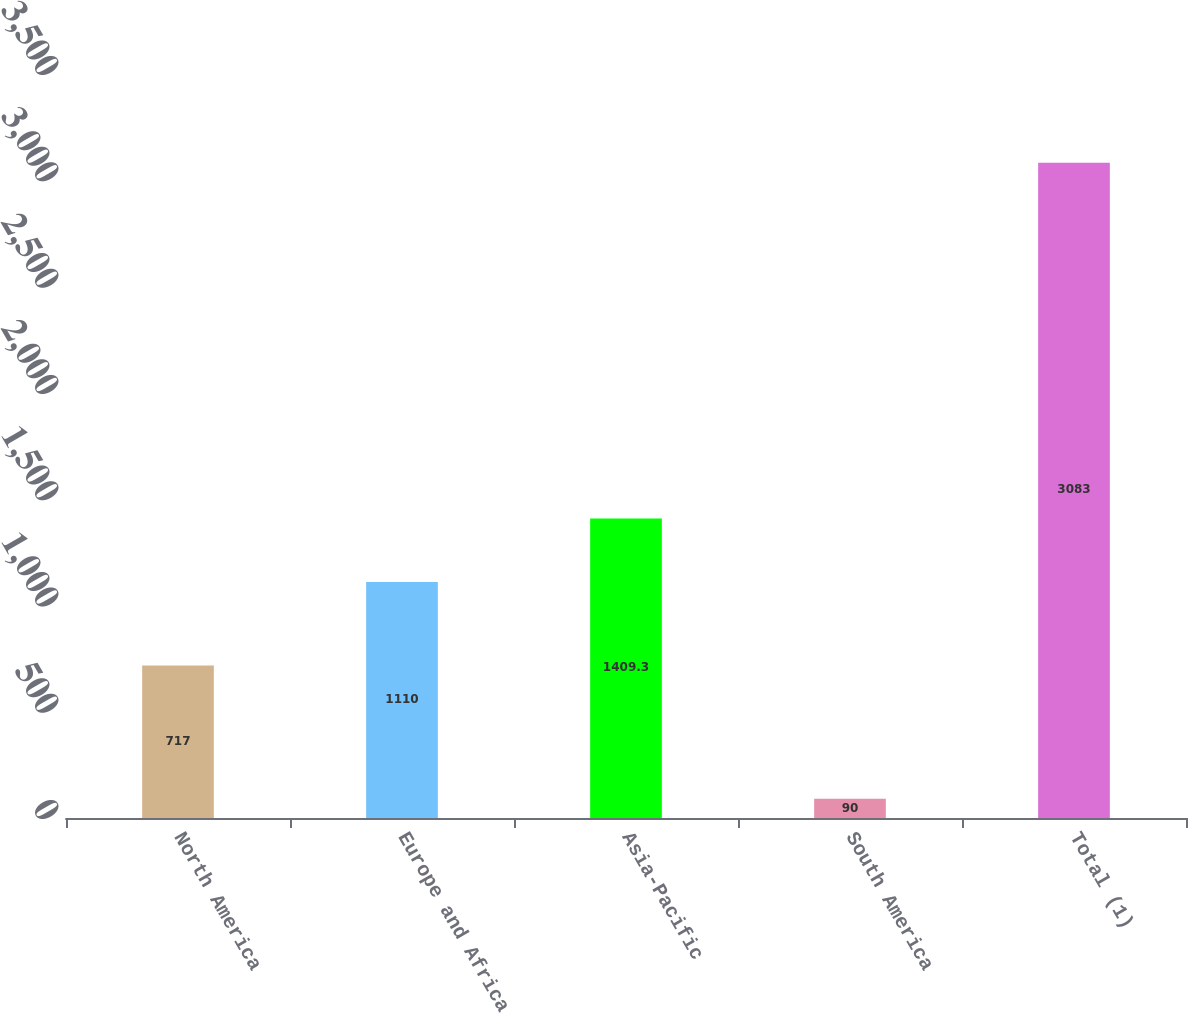Convert chart to OTSL. <chart><loc_0><loc_0><loc_500><loc_500><bar_chart><fcel>North America<fcel>Europe and Africa<fcel>Asia-Pacific<fcel>South America<fcel>Total (1)<nl><fcel>717<fcel>1110<fcel>1409.3<fcel>90<fcel>3083<nl></chart> 